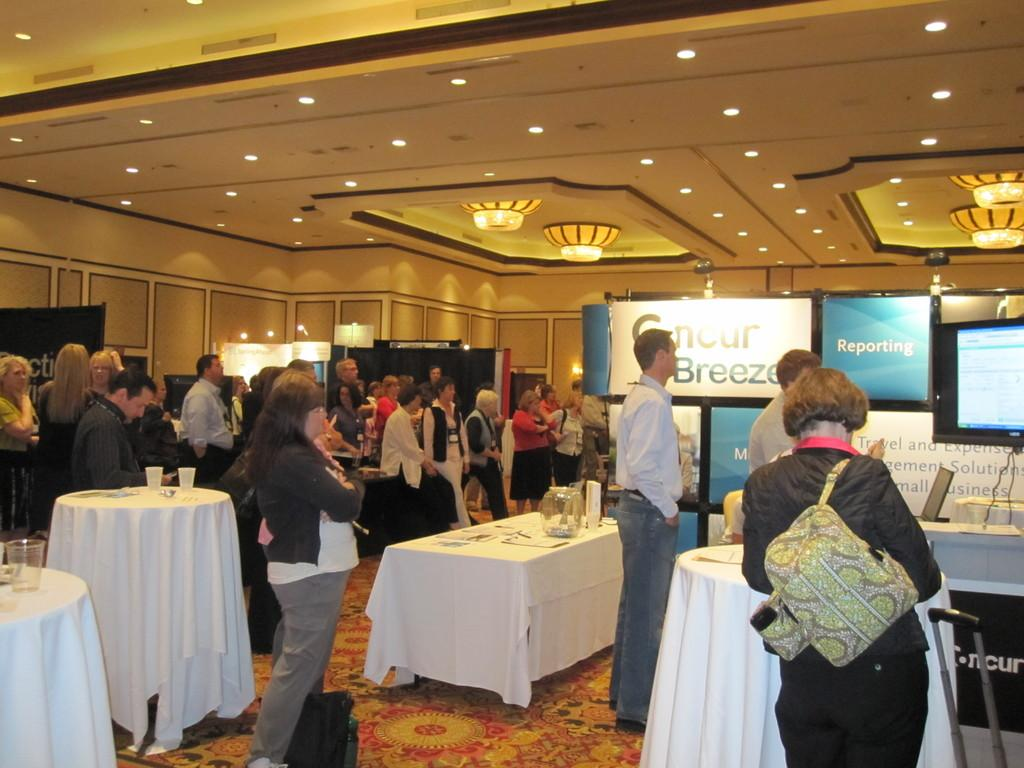How many people are in the image? There is a group of people in the image. What are the people doing in the image? The people are standing in the image. What object can be seen behind the people? There is a table in the image. What are the people looking at or interacting with in the image? There are televisions in front of the people. What type of pollution can be seen in the image? There is no pollution visible in the image. How many passengers are present in the image? There is no reference to passengers in the image; it features a group of people standing near televisions. 